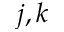Convert formula to latex. <formula><loc_0><loc_0><loc_500><loc_500>j , k</formula> 